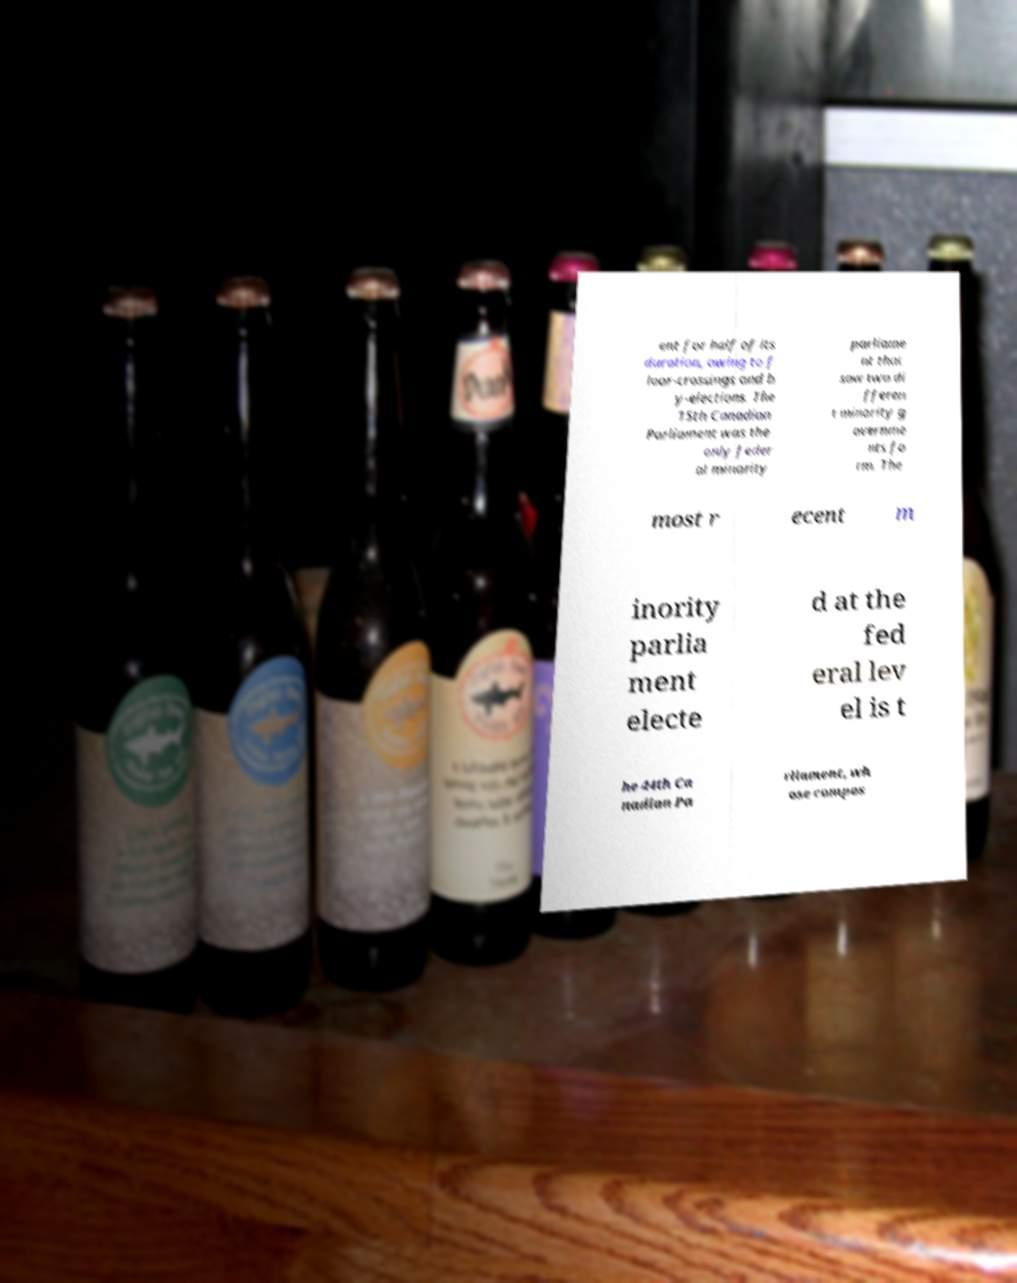I need the written content from this picture converted into text. Can you do that? ent for half of its duration, owing to f loor-crossings and b y-elections. The 15th Canadian Parliament was the only feder al minority parliame nt that saw two di fferen t minority g overnme nts fo rm. The most r ecent m inority parlia ment electe d at the fed eral lev el is t he 44th Ca nadian Pa rliament, wh ose compos 